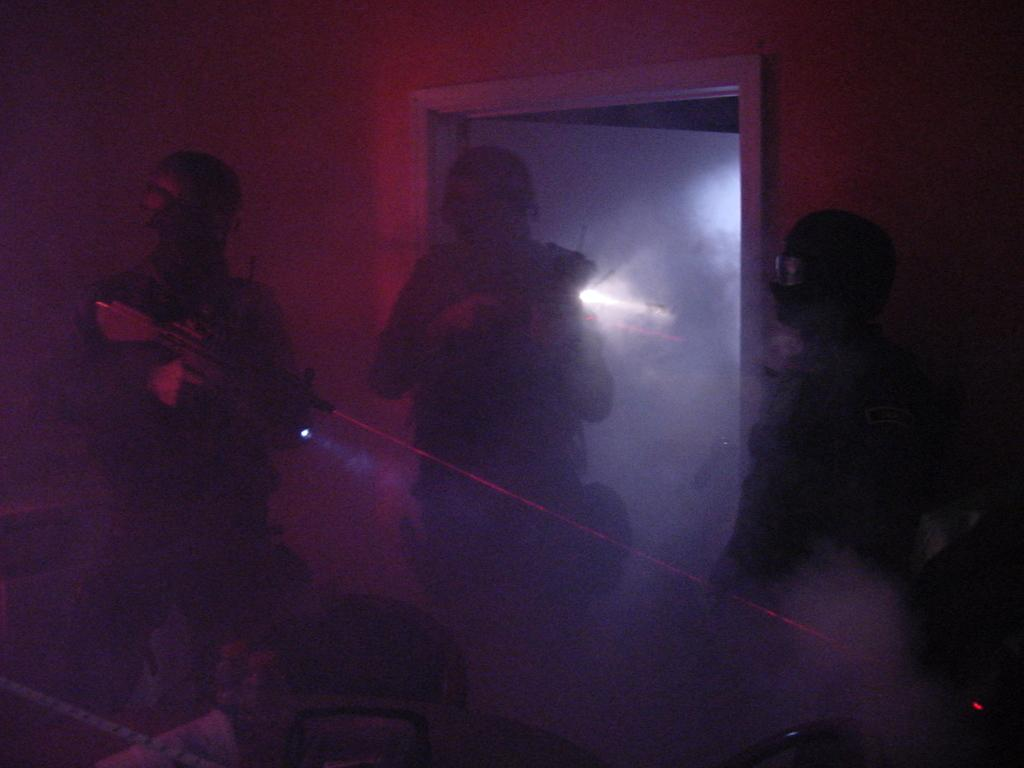Where was the image taken? The image was taken in a room. What is happening in the center of the image? There are three people in the center of the image. Can you describe the man on the left side of the image? The man on the left side of the image is standing and holding a rifle. What can be seen in the background of the image? There is a wall and a door in the background of the image. What type of horn can be heard in the image? There is no horn present in the image, and therefore no sound can be heard. Is there any magic happening in the image? There is no indication of magic in the image; it depicts people and a man holding a rifle in a room. 